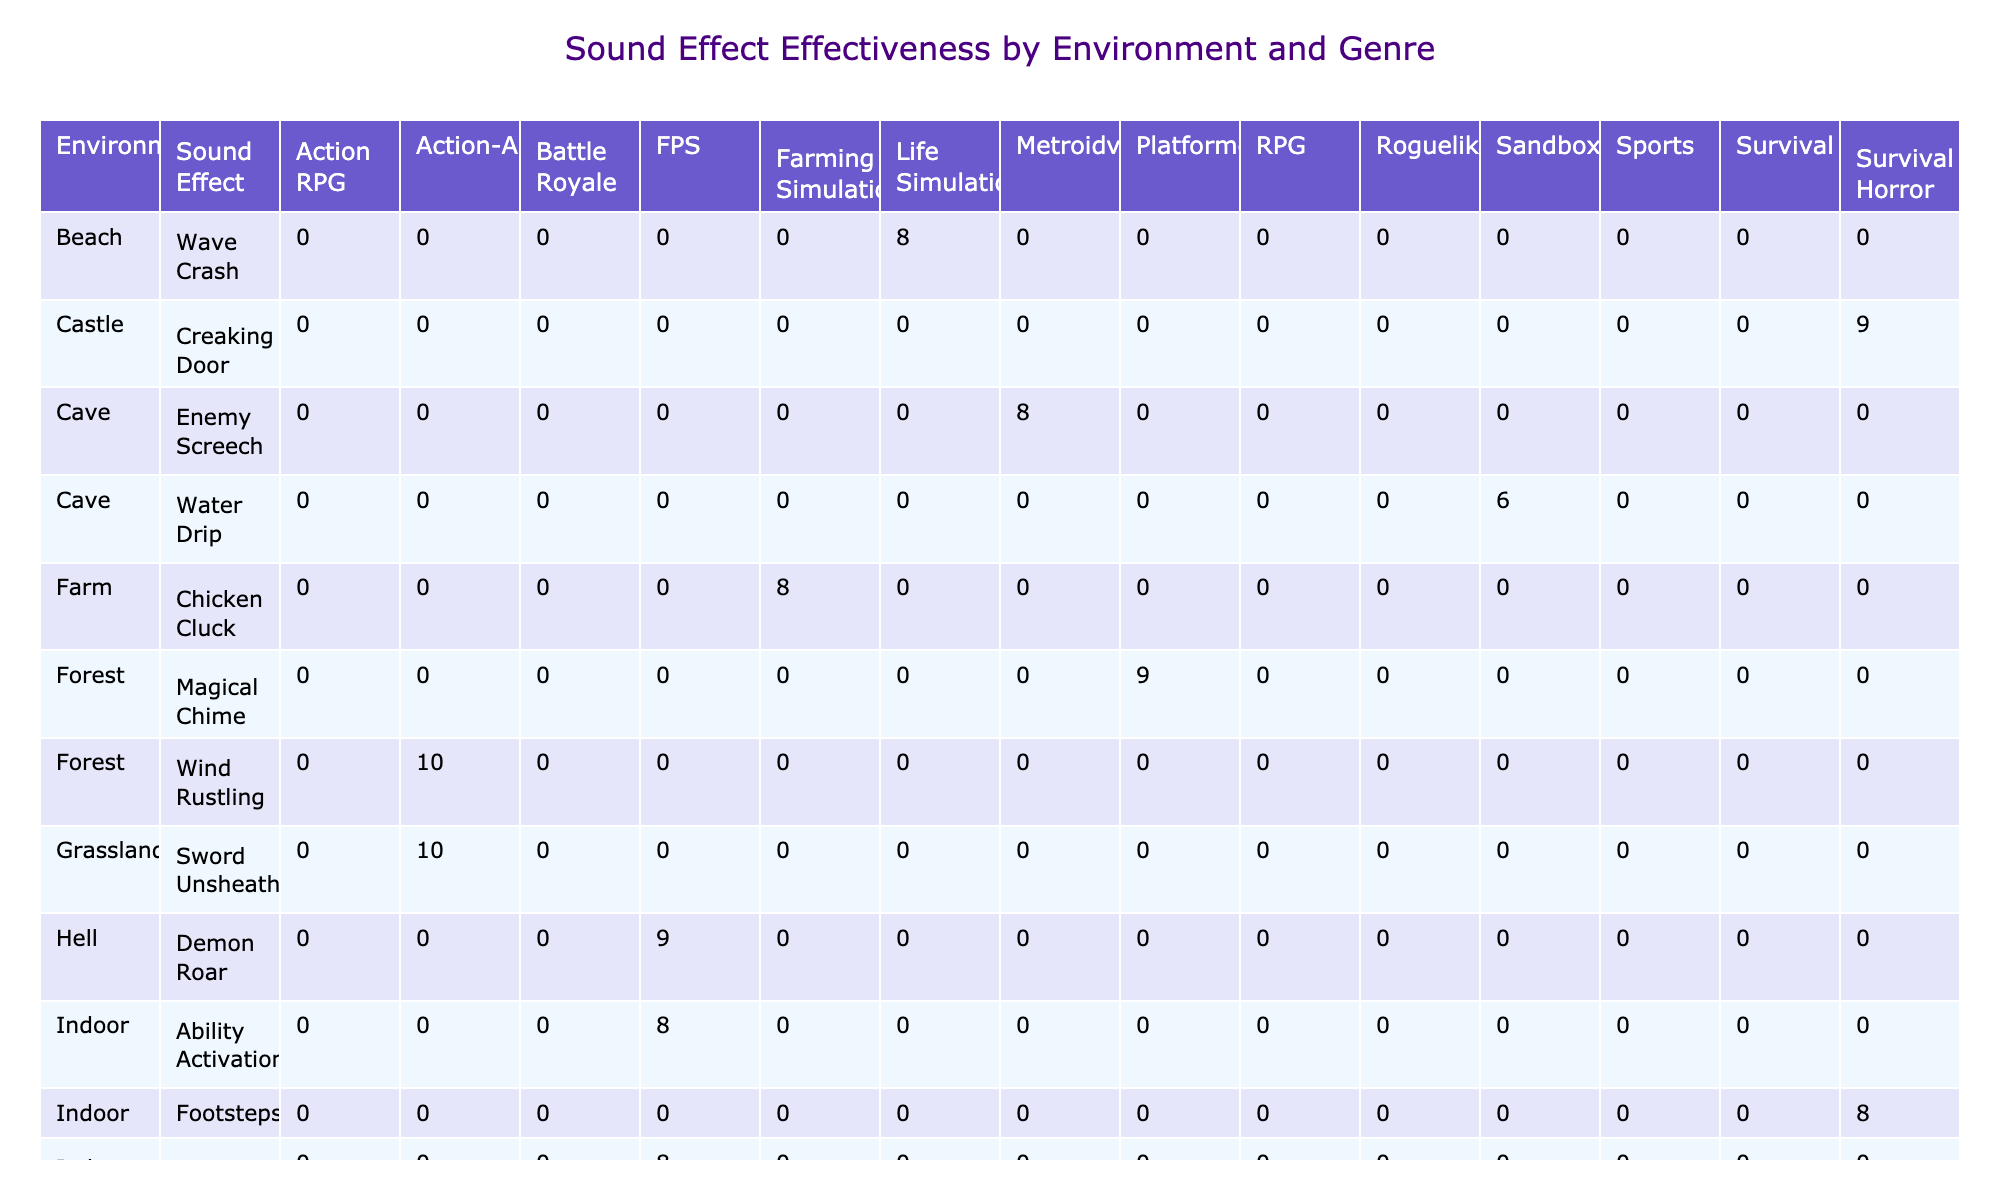What is the effectiveness rating for the "Wind Rustling" sound effect in the Forest environment? In the table, I look at the row corresponding to "Forest" in the 'Environment' column, which features the "Wind Rustling" sound effect. Checking the values under the "Effectiveness Rating" column, I see that the rating is 10.
Answer: 10 Which environment has the highest average effectiveness rating for sound effects? To determine this, I need to look at the effectiveness ratings for all environments. Calculating the average for each environment, I find: Outdoor (9.5), Indoor (8.0), Urban (8.0), Cave (7), Hell (9), Underworld (9), Beach (8), Village (7), Castle (9), Farm (8), Stadium (7), Grassland (10), and Forest (10). The environments with the highest averages are the Forest and Grassland with 10.
Answer: Forest and Grassland Does the "Explosion" sound effect have an effectiveness rating higher than 8? I examine the value under the row for "Explosion" in the Urban environment, checking its effectiveness rating. The rating is 9, which is indeed higher than 8.
Answer: Yes What is the total implementation time for sound effects in Action Adventure games? I look for the "Implementation Time" values for all rows where the genre is "Action-Adventure". The respective times are 6 hours for "Horse Gallop," 4 hours for "Wind Rustling," and 3 hours for "Sword Unsheathing." Adding these gives 6 + 4 + 3 = 13 hours.
Answer: 13 hours How many sound effects have an effectiveness rating of 10? Checking each row in the table, I identify the sound effects with a rating of 10. These are "Horse Gallop," "Sword Clash," "Wind Rustling," and "Sword Unsheathing." There are four sound effects that meet this criterion.
Answer: 4 Which sound effect in the Indoor environment received the lowest player feedback score? I examine the rows corresponding to the Indoor environment and identify the "Effectiveness Rating" and "Player Feedback Score." I see the "Footsteps" sound effect has a player feedback score of 7.9 and "Character Ultimate" has 7.8, making "Character Ultimate" the lowest in this environment.
Answer: Character Ultimate What is the average effectiveness rating for sound effects in FPS games? I look for the rows labeled as FPS in the genre column and find their effectiveness ratings: "Demon Roar" (9), "Character Ultimate" (8), and "Ability Activation" (8). I calculate the average as (9 + 8 + 8) / 3 = 8.33.
Answer: 8.33 Is the player feedback score for the "Creaking Door" sound effect higher than that of "Wave Crash"? I find the player feedback scores for the "Creaking Door" (8.8) and "Wave Crash" (9.5) sound effects, comparing them. The score for "Creaking Door" is lower than "Wave Crash."
Answer: No 